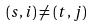<formula> <loc_0><loc_0><loc_500><loc_500>( s , i ) \ne ( t , j )</formula> 